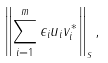Convert formula to latex. <formula><loc_0><loc_0><loc_500><loc_500>\left \| \sum _ { i = 1 } ^ { m } \epsilon _ { i } u _ { i } v _ { i } ^ { * } \right \| _ { s } ,</formula> 